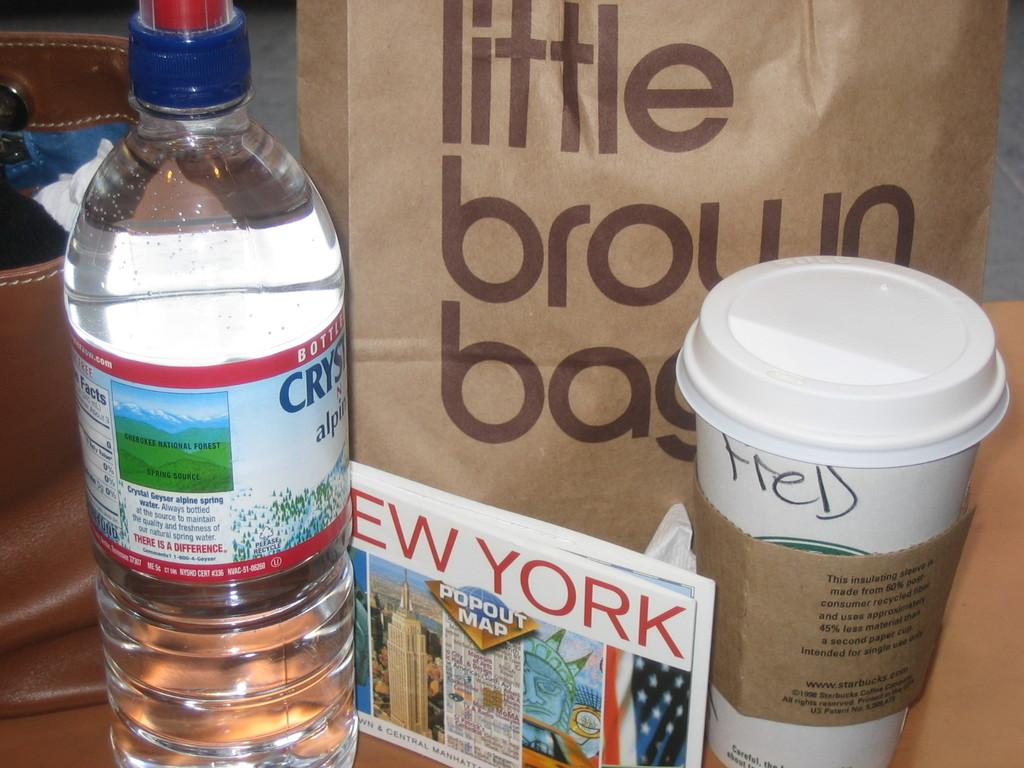<image>
Provide a brief description of the given image. A cup with the name Fred on it is in front of a bag that has the words little brown bag on it. 